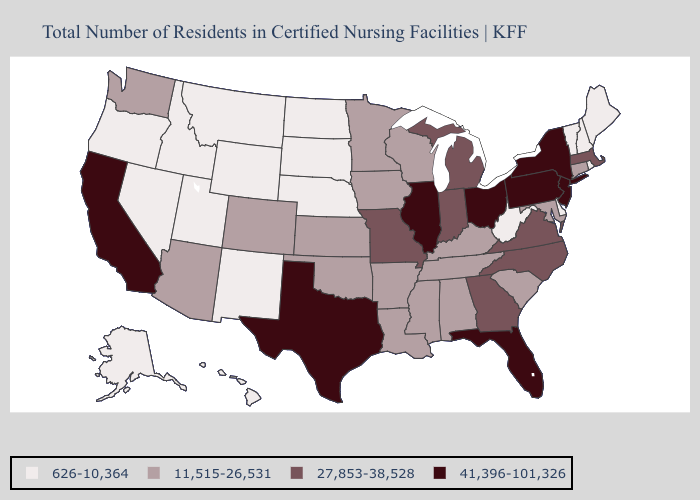What is the value of Wisconsin?
Write a very short answer. 11,515-26,531. Among the states that border Tennessee , which have the lowest value?
Short answer required. Alabama, Arkansas, Kentucky, Mississippi. Name the states that have a value in the range 11,515-26,531?
Answer briefly. Alabama, Arizona, Arkansas, Colorado, Connecticut, Iowa, Kansas, Kentucky, Louisiana, Maryland, Minnesota, Mississippi, Oklahoma, South Carolina, Tennessee, Washington, Wisconsin. Does the first symbol in the legend represent the smallest category?
Short answer required. Yes. Name the states that have a value in the range 27,853-38,528?
Concise answer only. Georgia, Indiana, Massachusetts, Michigan, Missouri, North Carolina, Virginia. Does New York have the highest value in the USA?
Give a very brief answer. Yes. Among the states that border Georgia , does North Carolina have the highest value?
Short answer required. No. Does Nevada have the highest value in the West?
Quick response, please. No. Does Illinois have the highest value in the MidWest?
Quick response, please. Yes. Name the states that have a value in the range 626-10,364?
Concise answer only. Alaska, Delaware, Hawaii, Idaho, Maine, Montana, Nebraska, Nevada, New Hampshire, New Mexico, North Dakota, Oregon, Rhode Island, South Dakota, Utah, Vermont, West Virginia, Wyoming. What is the value of Washington?
Short answer required. 11,515-26,531. Which states have the highest value in the USA?
Quick response, please. California, Florida, Illinois, New Jersey, New York, Ohio, Pennsylvania, Texas. Which states have the lowest value in the USA?
Write a very short answer. Alaska, Delaware, Hawaii, Idaho, Maine, Montana, Nebraska, Nevada, New Hampshire, New Mexico, North Dakota, Oregon, Rhode Island, South Dakota, Utah, Vermont, West Virginia, Wyoming. Among the states that border Ohio , does West Virginia have the lowest value?
Quick response, please. Yes. Name the states that have a value in the range 27,853-38,528?
Concise answer only. Georgia, Indiana, Massachusetts, Michigan, Missouri, North Carolina, Virginia. 